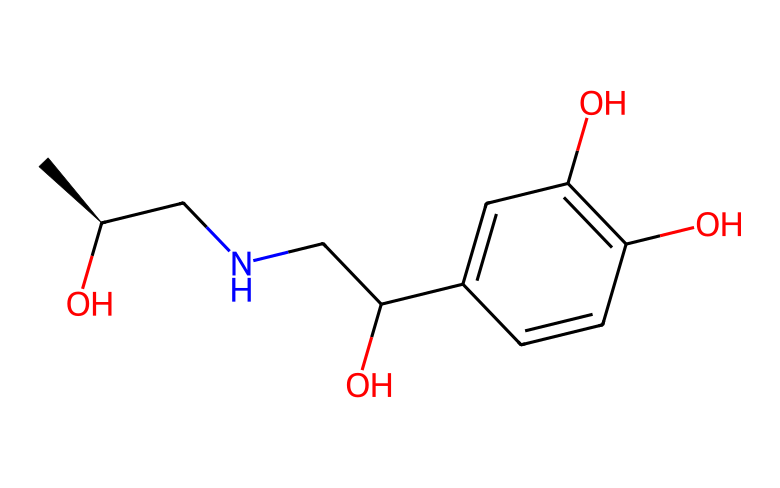What is the molecular formula of this compound? To find the molecular formula, count the number of each type of atom represented in the SMILES structure. The constituents include Carbon (C), Hydrogen (H), Nitrogen (N), and Oxygen (O). The total counts yield C9, H13, N, and O3.
Answer: C9H13NO3 How many chiral centers are present in this molecule? By examining the structure, chiral centers are identified by looking for carbon atoms attached to four different groups. There is one such carbon (the carbon connected to the nitrogen) in the provided structure.
Answer: 1 What functional groups can be identified in this compound? Analyzing the SMILES representation reveals both hydroxyl (–OH) groups and an amine (–NH) group. The presence of two hydroxyls and one amine indicates the functional groups present in this molecule.
Answer: hydroxyl and amine What role does epinephrine play in the body? Recognizing epinephrine's biological function is important; it acts as a hormone and neurotransmitter that increases heart rate and opens airways in the lungs, which is critical in emergency situations.
Answer: stimulant What is the significance of the hydroxyl groups in this compound? Hydroxyl groups increase water solubility and can enhance reactivity, making the compound more effective for therapeutic uses by allowing better interaction with biological molecules.
Answer: increased solubility How does the nitrogen atom affect the overall activity of epinephrine? The nitrogen atom is part of the amine group, which contributes to the molecule's basicity and its ability to bind to receptors, playing a key role in its adrenergic activity.
Answer: enhances receptor binding 